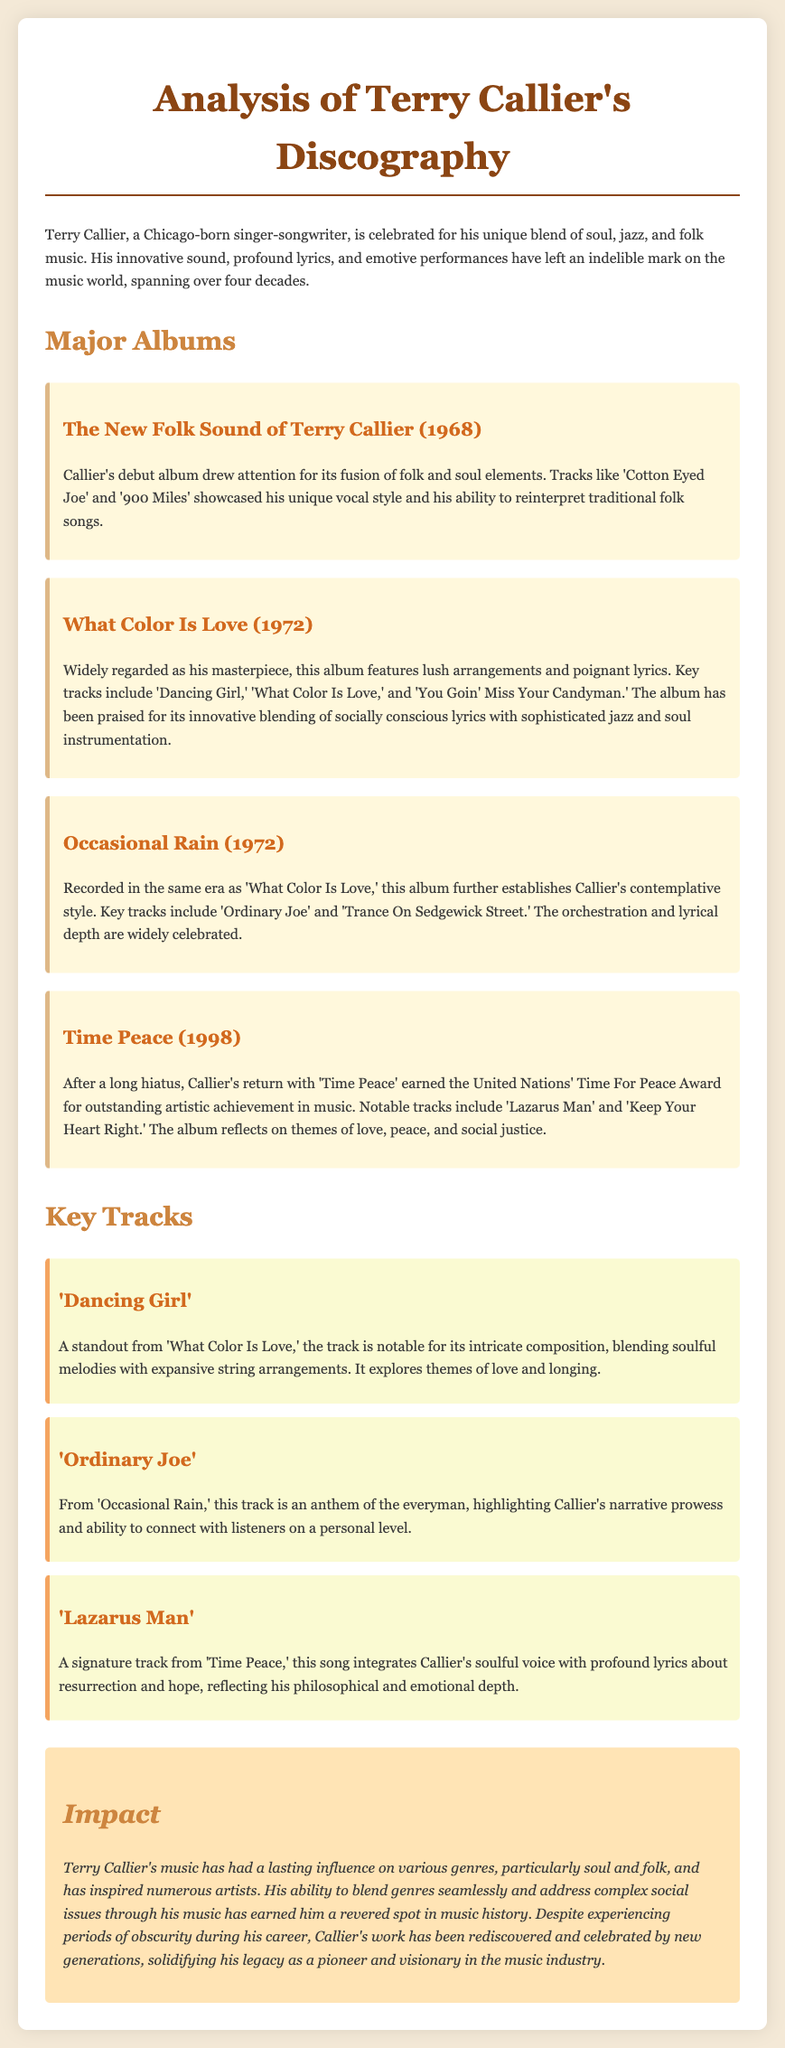what is Terry Callier's debut album? The document states that Terry Callier's debut album is "The New Folk Sound of Terry Callier."
Answer: The New Folk Sound of Terry Callier what year was "What Color Is Love" released? The fact sheet specifies that "What Color Is Love" was released in 1972.
Answer: 1972 which track is featured in "Occasional Rain"? The document mentions "Ordinary Joe" as a key track from "Occasional Rain."
Answer: Ordinary Joe who awarded Terry Callier the Time For Peace Award? The fact sheet indicates that the United Nations awarded Terry Callier the Time For Peace Award.
Answer: United Nations what themes does "Lazarus Man" explore? According to the document, "Lazarus Man" reflects on themes of resurrection and hope.
Answer: resurrection and hope how did Terry Callier's music impact various genres? The document highlights that Terry Callier's music has influenced particularly soul and folk genres.
Answer: soul and folk what is the overall impact of Terry Callier's music? The fact sheet states that his music has had a lasting influence and has inspired numerous artists over the years.
Answer: lasting influence which song from "What Color Is Love" explores love and longing? The document indicates that "Dancing Girl" explores themes of love and longing.
Answer: Dancing Girl how long did Terry Callier's career span? The document specifies that Terry Callier's career spanned over four decades.
Answer: over four decades 